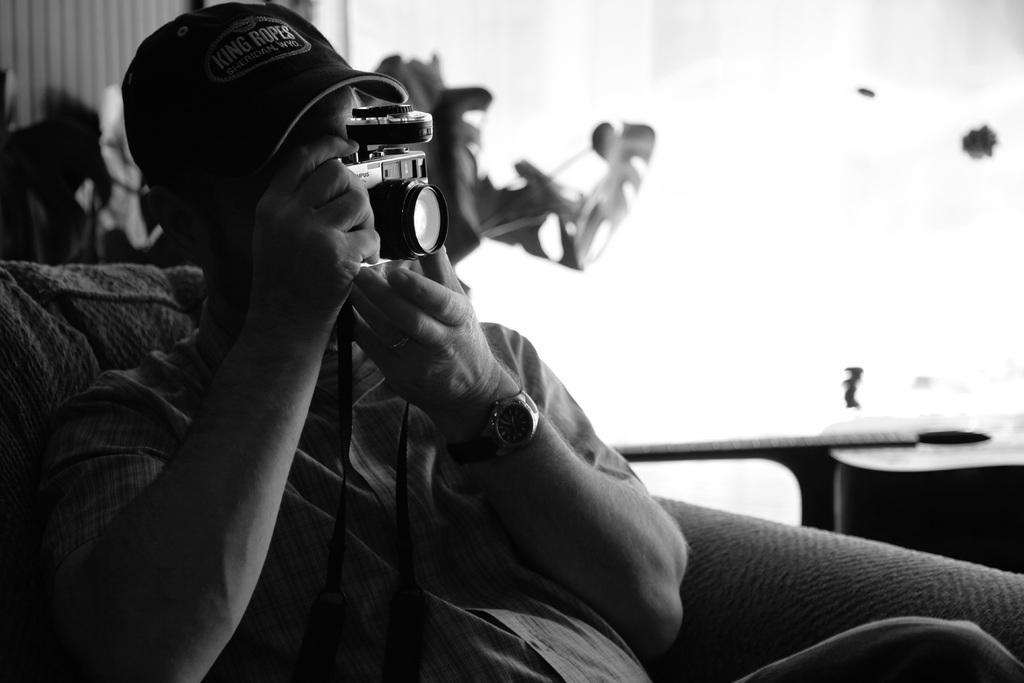What is the color scheme of the image? The image is black and white. What is the man in the image doing? The man is sitting on a couch and using a camera. What can be seen in the background of the image? There is a houseplant in the background. What type of letters can be seen on the sky in the image? There are no letters visible on the sky in the image, as it is a black and white image with no text or writing present. 